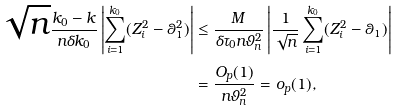<formula> <loc_0><loc_0><loc_500><loc_500>\sqrt { n } \frac { k _ { 0 } - k } { n \delta k _ { 0 } } \left | \sum _ { i = 1 } ^ { k _ { 0 } } ( Z _ { i } ^ { 2 } - \theta _ { 1 } ^ { 2 } ) \right | & \leq \frac { M } { \delta \tau _ { 0 } n \vartheta _ { n } ^ { 2 } } \left | \frac { 1 } { \sqrt { n } } \sum _ { i = 1 } ^ { k _ { 0 } } ( Z _ { i } ^ { 2 } - \theta _ { 1 } ) \right | \\ & = \frac { O _ { p } ( 1 ) } { n \vartheta _ { n } ^ { 2 } } = o _ { p } ( 1 ) ,</formula> 